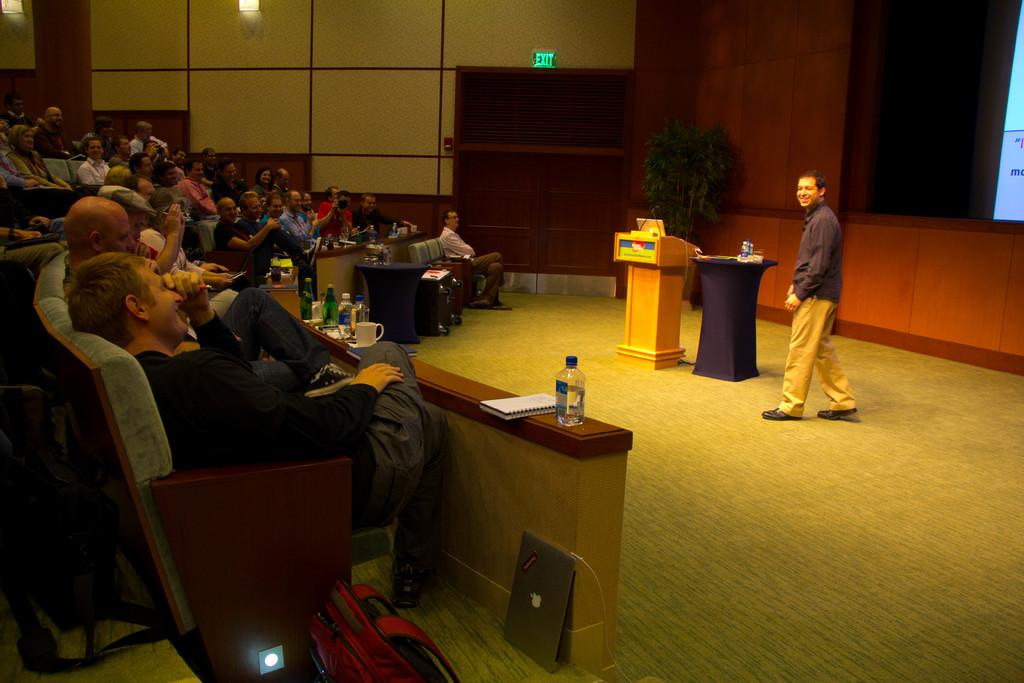What are the people in the image doing? There is a group of people sitting in chairs, which suggests they might be attending an event or gathering. What is on the table in the image? There is a cup, a bottle, a book, and a laptop on the table. Can you describe the background of the image? There is a plant, a screen, and a man walking towards a podium in the background. What type of potato is being washed in the image? There is no potato or washing activity present in the image. What is the mysterious thing on the table that nobody seems to notice? There is no mysterious thing on the table that is not mentioned in the provided facts. 